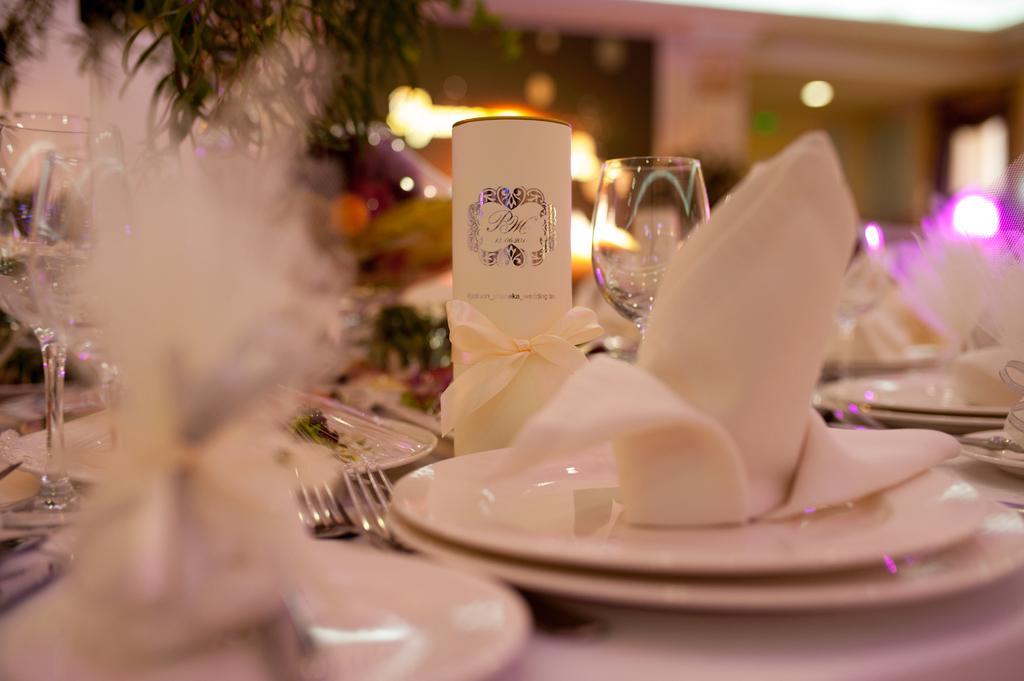How would you summarize this image in a sentence or two? In this picture we can see a table, there are some plates, forks, glasses present on the table, in the background we can see lights, there are some tissue papers on these plates. 